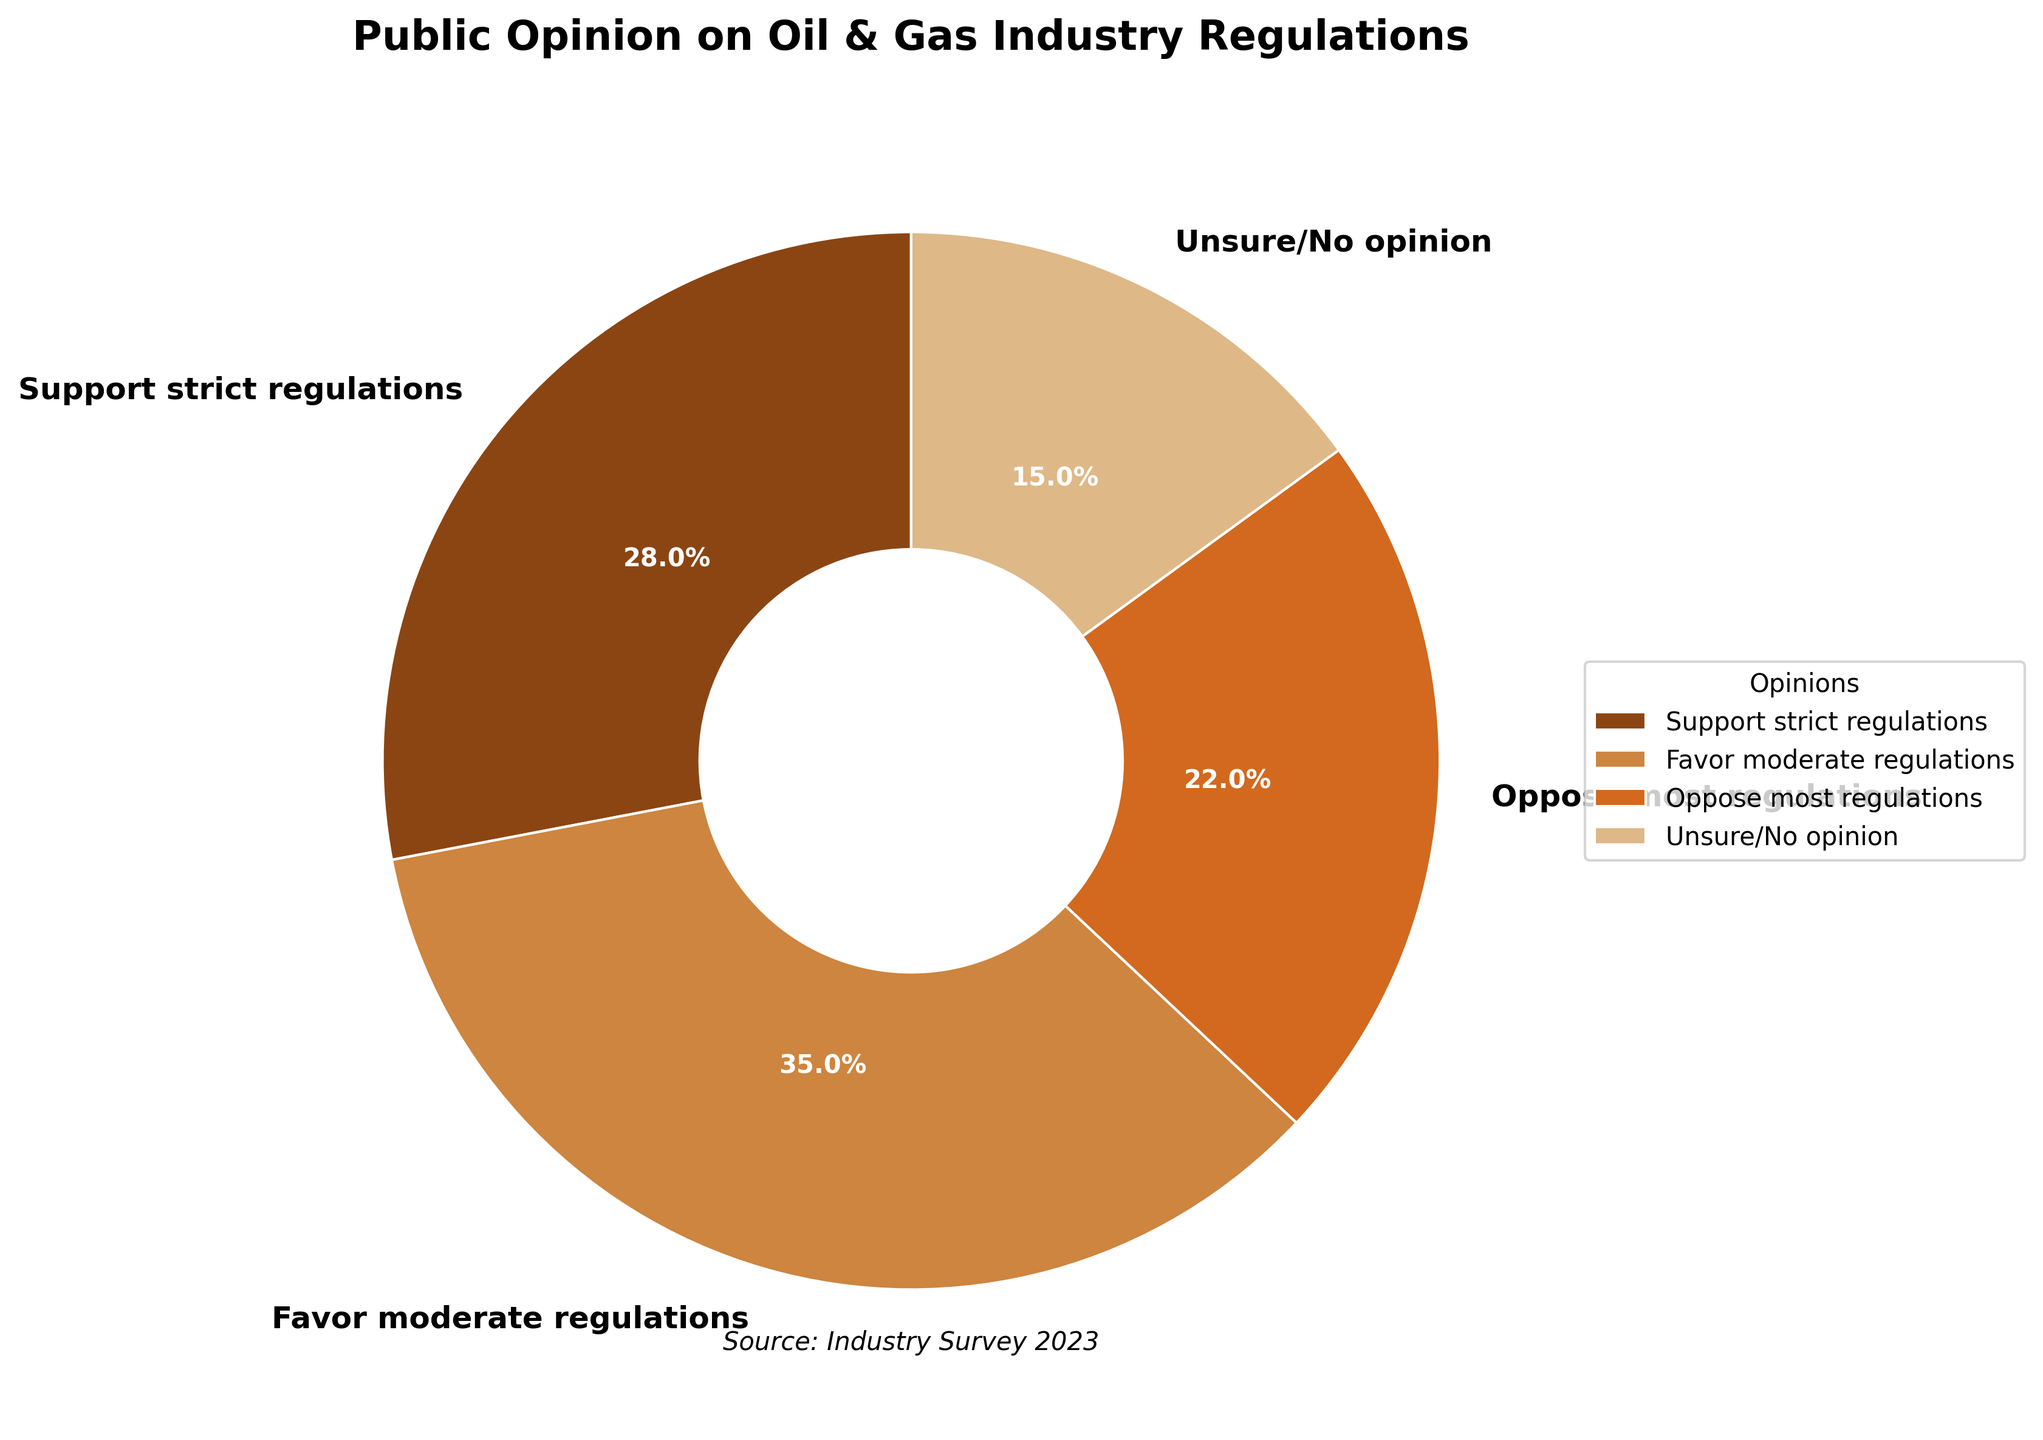Which opinion category has the highest percentage? The pie chart shows the different categories of opinions on regulations. The category with the largest slice represents the highest percentage. By looking at the chart, the "Favor moderate regulations" slice is the largest.
Answer: Favor moderate regulations What is the combined percentage of people who support either strict or moderate regulations? To find the combined percentage, you need to add the percentages of the "Support strict regulations" and "Favor moderate regulations" categories. The chart shows these percentages as 28% and 35% respectively. The sum is 28 + 35.
Answer: 63% How does the percentage of people who are unsure/no opinion compare to those who oppose most regulations? This is a comparison between the "Unsure/No opinion" and "Oppose most regulations" categories. By looking at the chart, we see that "Unsure/No opinion" is 15%, and "Oppose most regulations" is 22%. 15% is less than 22%.
Answer: Less Which group has the smallest percentage? The smallest slice on the pie chart represents the group with the smallest percentage. By examining the chart, it's clear that the "Unsure/No opinion" category has the smallest slice.
Answer: Unsure/No opinion What is the difference in percentage between those who favor moderate regulations and those who support strict regulations? To find this difference, subtract the percentage of the "Support strict regulations" category from the "Favor moderate regulations" category. The chart shows 35% for moderate and 28% for strict. The difference is 35 - 28.
Answer: 7% What percentage of people are either opposed to most regulations or unsure/no opinion? Add the percentages of the "Oppose most regulations" and "Unsure/No opinion" categories. The chart shows these as 22% and 15% respectively. The sum is 22 + 15.
Answer: 37% Which opinion category is represented by the darkest color in the pie chart? The chart uses specific colors for each category, and the darkest color should be identified by comparing the colors visually. The data indicates that the darkest color represents the "Support strict regulations" category.
Answer: Support strict regulations What is the average percentage of the opinions that favor some form of regulation (either strict or moderate)? To find the average, add the percentages of the "Support strict regulations" and "Favor moderate regulations" categories and then divide by 2. The chart shows 28% and 35%, so the average is (28 + 35) / 2.
Answer: 31.5% Is the number of people who oppose most regulations greater than those who are unsure/no opinion? Compare the percentages of the "Oppose most regulations" and "Unsure/No opinion" categories. The chart shows 22% for oppose and 15% for unsure. Since 22% is greater than 15%, the answer is yes.
Answer: Yes How many percentage points more likely are people to favor moderate regulations compared to opposing most regulations? To determine this, subtract the percentage of the "Oppose most regulations" category from the "Favor moderate regulations" category. The chart indicates 35% for moderate and 22% for opposing. The difference is 35 - 22.
Answer: 13% 